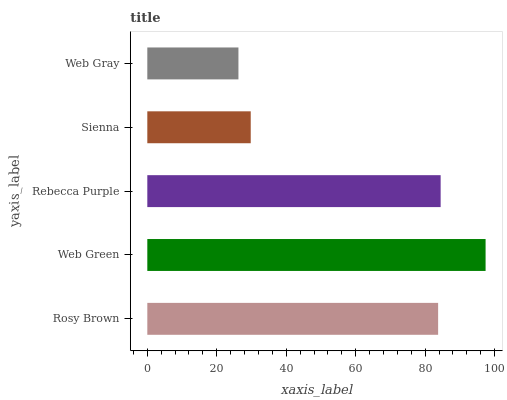Is Web Gray the minimum?
Answer yes or no. Yes. Is Web Green the maximum?
Answer yes or no. Yes. Is Rebecca Purple the minimum?
Answer yes or no. No. Is Rebecca Purple the maximum?
Answer yes or no. No. Is Web Green greater than Rebecca Purple?
Answer yes or no. Yes. Is Rebecca Purple less than Web Green?
Answer yes or no. Yes. Is Rebecca Purple greater than Web Green?
Answer yes or no. No. Is Web Green less than Rebecca Purple?
Answer yes or no. No. Is Rosy Brown the high median?
Answer yes or no. Yes. Is Rosy Brown the low median?
Answer yes or no. Yes. Is Rebecca Purple the high median?
Answer yes or no. No. Is Sienna the low median?
Answer yes or no. No. 